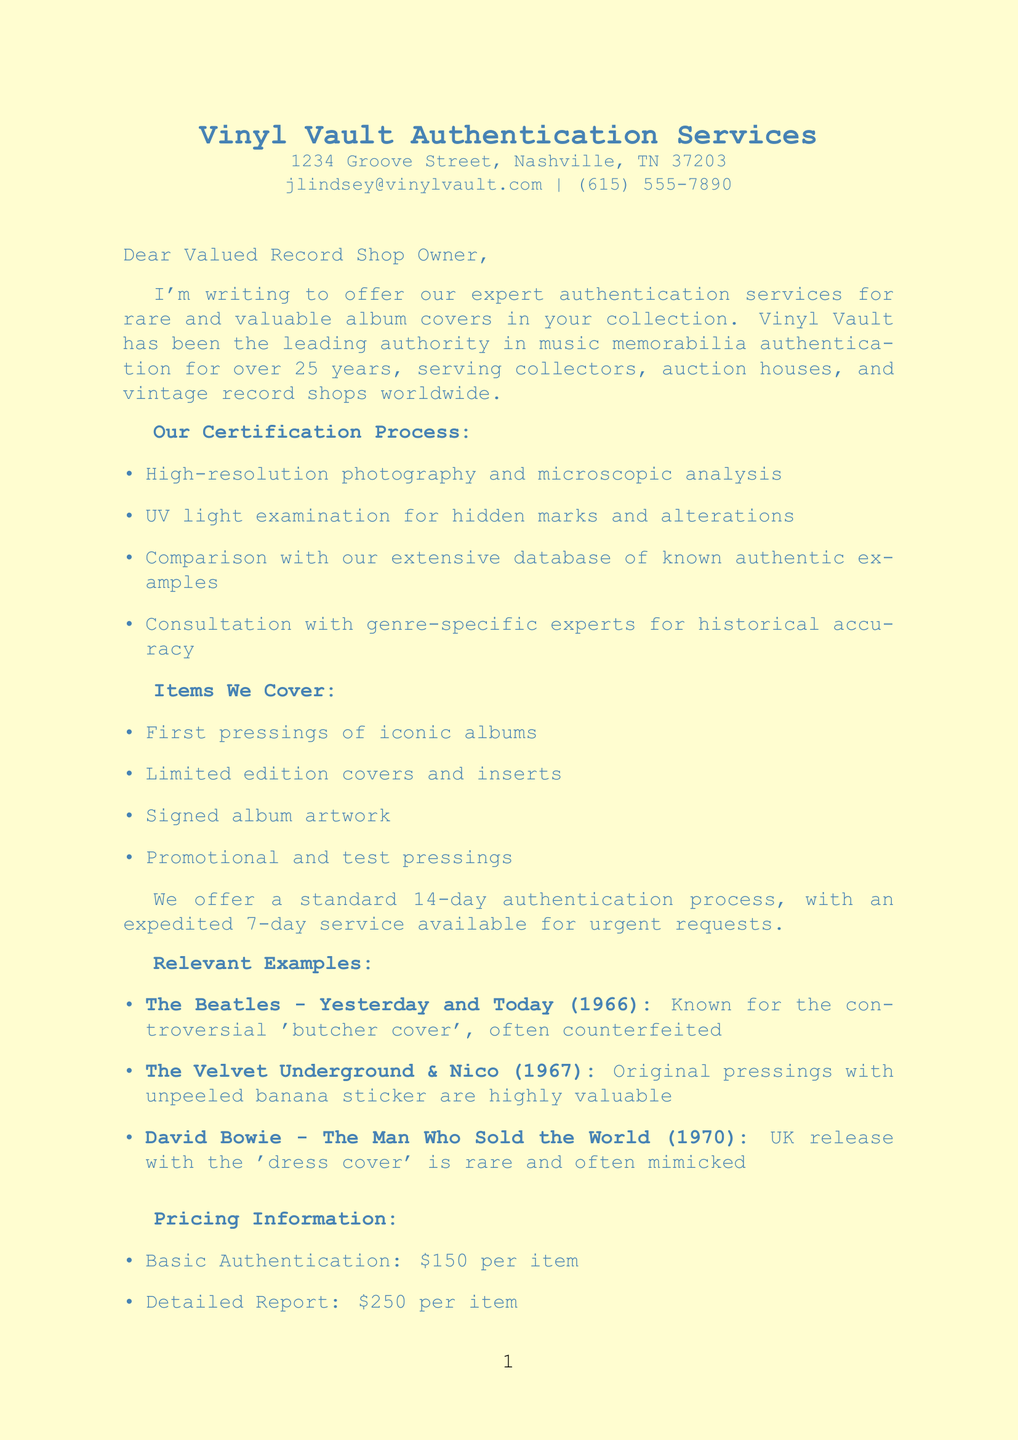What is the name of the authenticator? The document mentions the authenticator's name as John Lindsey.
Answer: John Lindsey What is the cost of the detailed report? The pricing section specifies the detailed report cost as $250 per item.
Answer: $250 per item What is the standard authentication process turnaround time? The letter states that the standard authentication process takes 14 days.
Answer: 14 days Which famous album is known for the 'butcher cover'? The document lists "The Beatles - Yesterday and Today" as the album associated with the 'butcher cover'.
Answer: The Beatles - Yesterday and Today What types of items are covered by the authentication service? The document lists several item types including first pressings, limited editions, signed artwork, and promotional pressings.
Answer: First pressings, limited edition covers and inserts, signed album artwork, promotional and test pressings What benefit does the letter mention for shop owners regarding customer confidence? It states an increased customer confidence in inventory as a benefit for shop owners.
Answer: Increased customer confidence in your inventory How many years has Vinyl Vault been in service? The letter mentions that Vinyl Vault has been in service for over 25 years.
Answer: Over 25 years What is the discounted price for 10 authenticated items? The pricing section details a 15% discount for 10 or more items, making the cost $212.50 per item after the discount.
Answer: $212.50 per item What is the call to action at the end of the letter? The letter encourages readers to contact them to schedule free authentication or to discuss tailored services.
Answer: Contact us to schedule your free authentication or to discuss how we can tailor our services to your shop's needs 